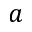<formula> <loc_0><loc_0><loc_500><loc_500>a</formula> 